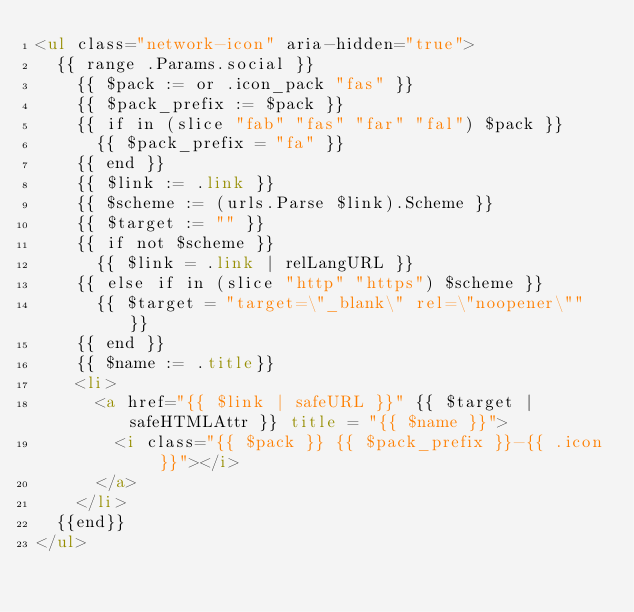<code> <loc_0><loc_0><loc_500><loc_500><_HTML_><ul class="network-icon" aria-hidden="true">
  {{ range .Params.social }}
    {{ $pack := or .icon_pack "fas" }}
    {{ $pack_prefix := $pack }}
    {{ if in (slice "fab" "fas" "far" "fal") $pack }}
      {{ $pack_prefix = "fa" }}
    {{ end }}
    {{ $link := .link }}
    {{ $scheme := (urls.Parse $link).Scheme }}
    {{ $target := "" }}
    {{ if not $scheme }}
      {{ $link = .link | relLangURL }}
    {{ else if in (slice "http" "https") $scheme }}
      {{ $target = "target=\"_blank\" rel=\"noopener\"" }}
    {{ end }}
    {{ $name := .title}}
    <li>
      <a href="{{ $link | safeURL }}" {{ $target | safeHTMLAttr }} title = "{{ $name }}">
        <i class="{{ $pack }} {{ $pack_prefix }}-{{ .icon }}"></i>
      </a>
    </li>
  {{end}}
</ul>
</code> 